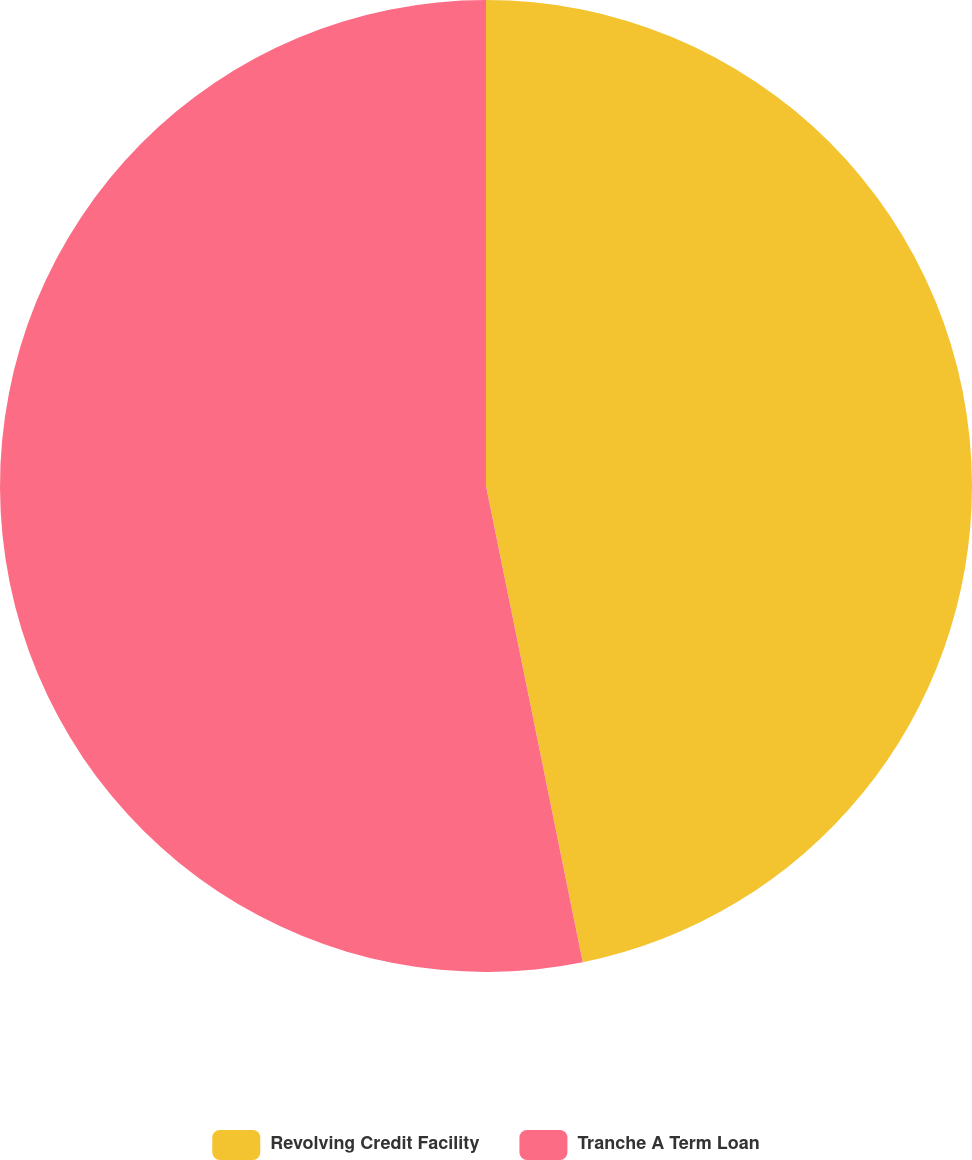Convert chart to OTSL. <chart><loc_0><loc_0><loc_500><loc_500><pie_chart><fcel>Revolving Credit Facility<fcel>Tranche A Term Loan<nl><fcel>46.81%<fcel>53.19%<nl></chart> 